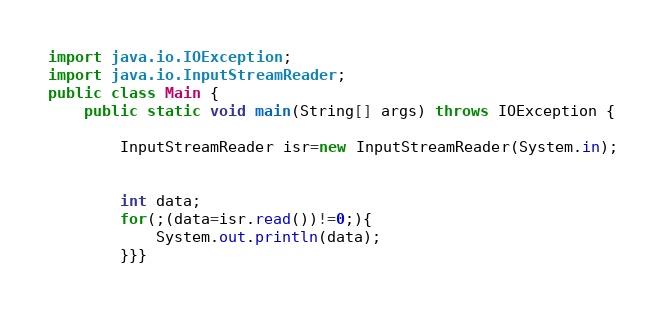<code> <loc_0><loc_0><loc_500><loc_500><_Java_>import java.io.IOException;
import java.io.InputStreamReader;
public class Main {
	public static void main(String[] args) throws IOException {
		
		InputStreamReader isr=new InputStreamReader(System.in);
		
		
	    int data;
	    for(;(data=isr.read())!=0;){
	    	System.out.println(data);
	    }}}</code> 